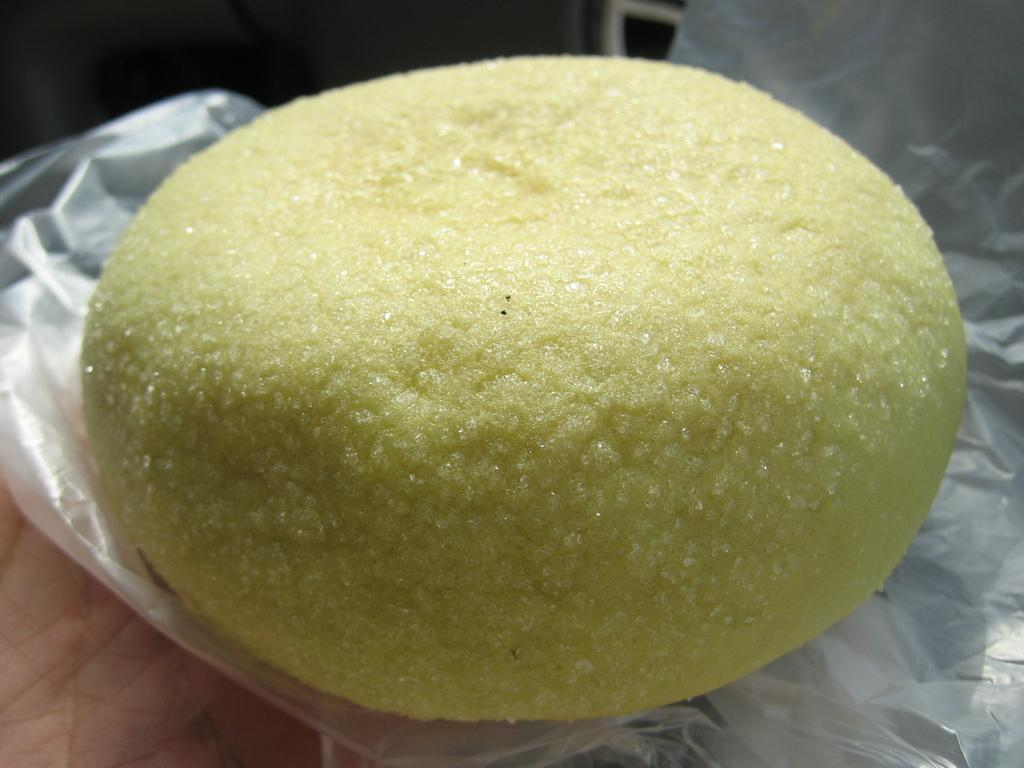What part of a person can be seen in the image? A person's hand is visible in the image. What is the person holding in the image? The person is holding a cover in the image. What is on top of the cover? The cover has food on it. Can you describe the background of the image? The background of the image is blurry. How far away is the person controlling the wound in the image? There is no person controlling a wound in the image; the image only shows a person's hand holding a cover with food on it. 